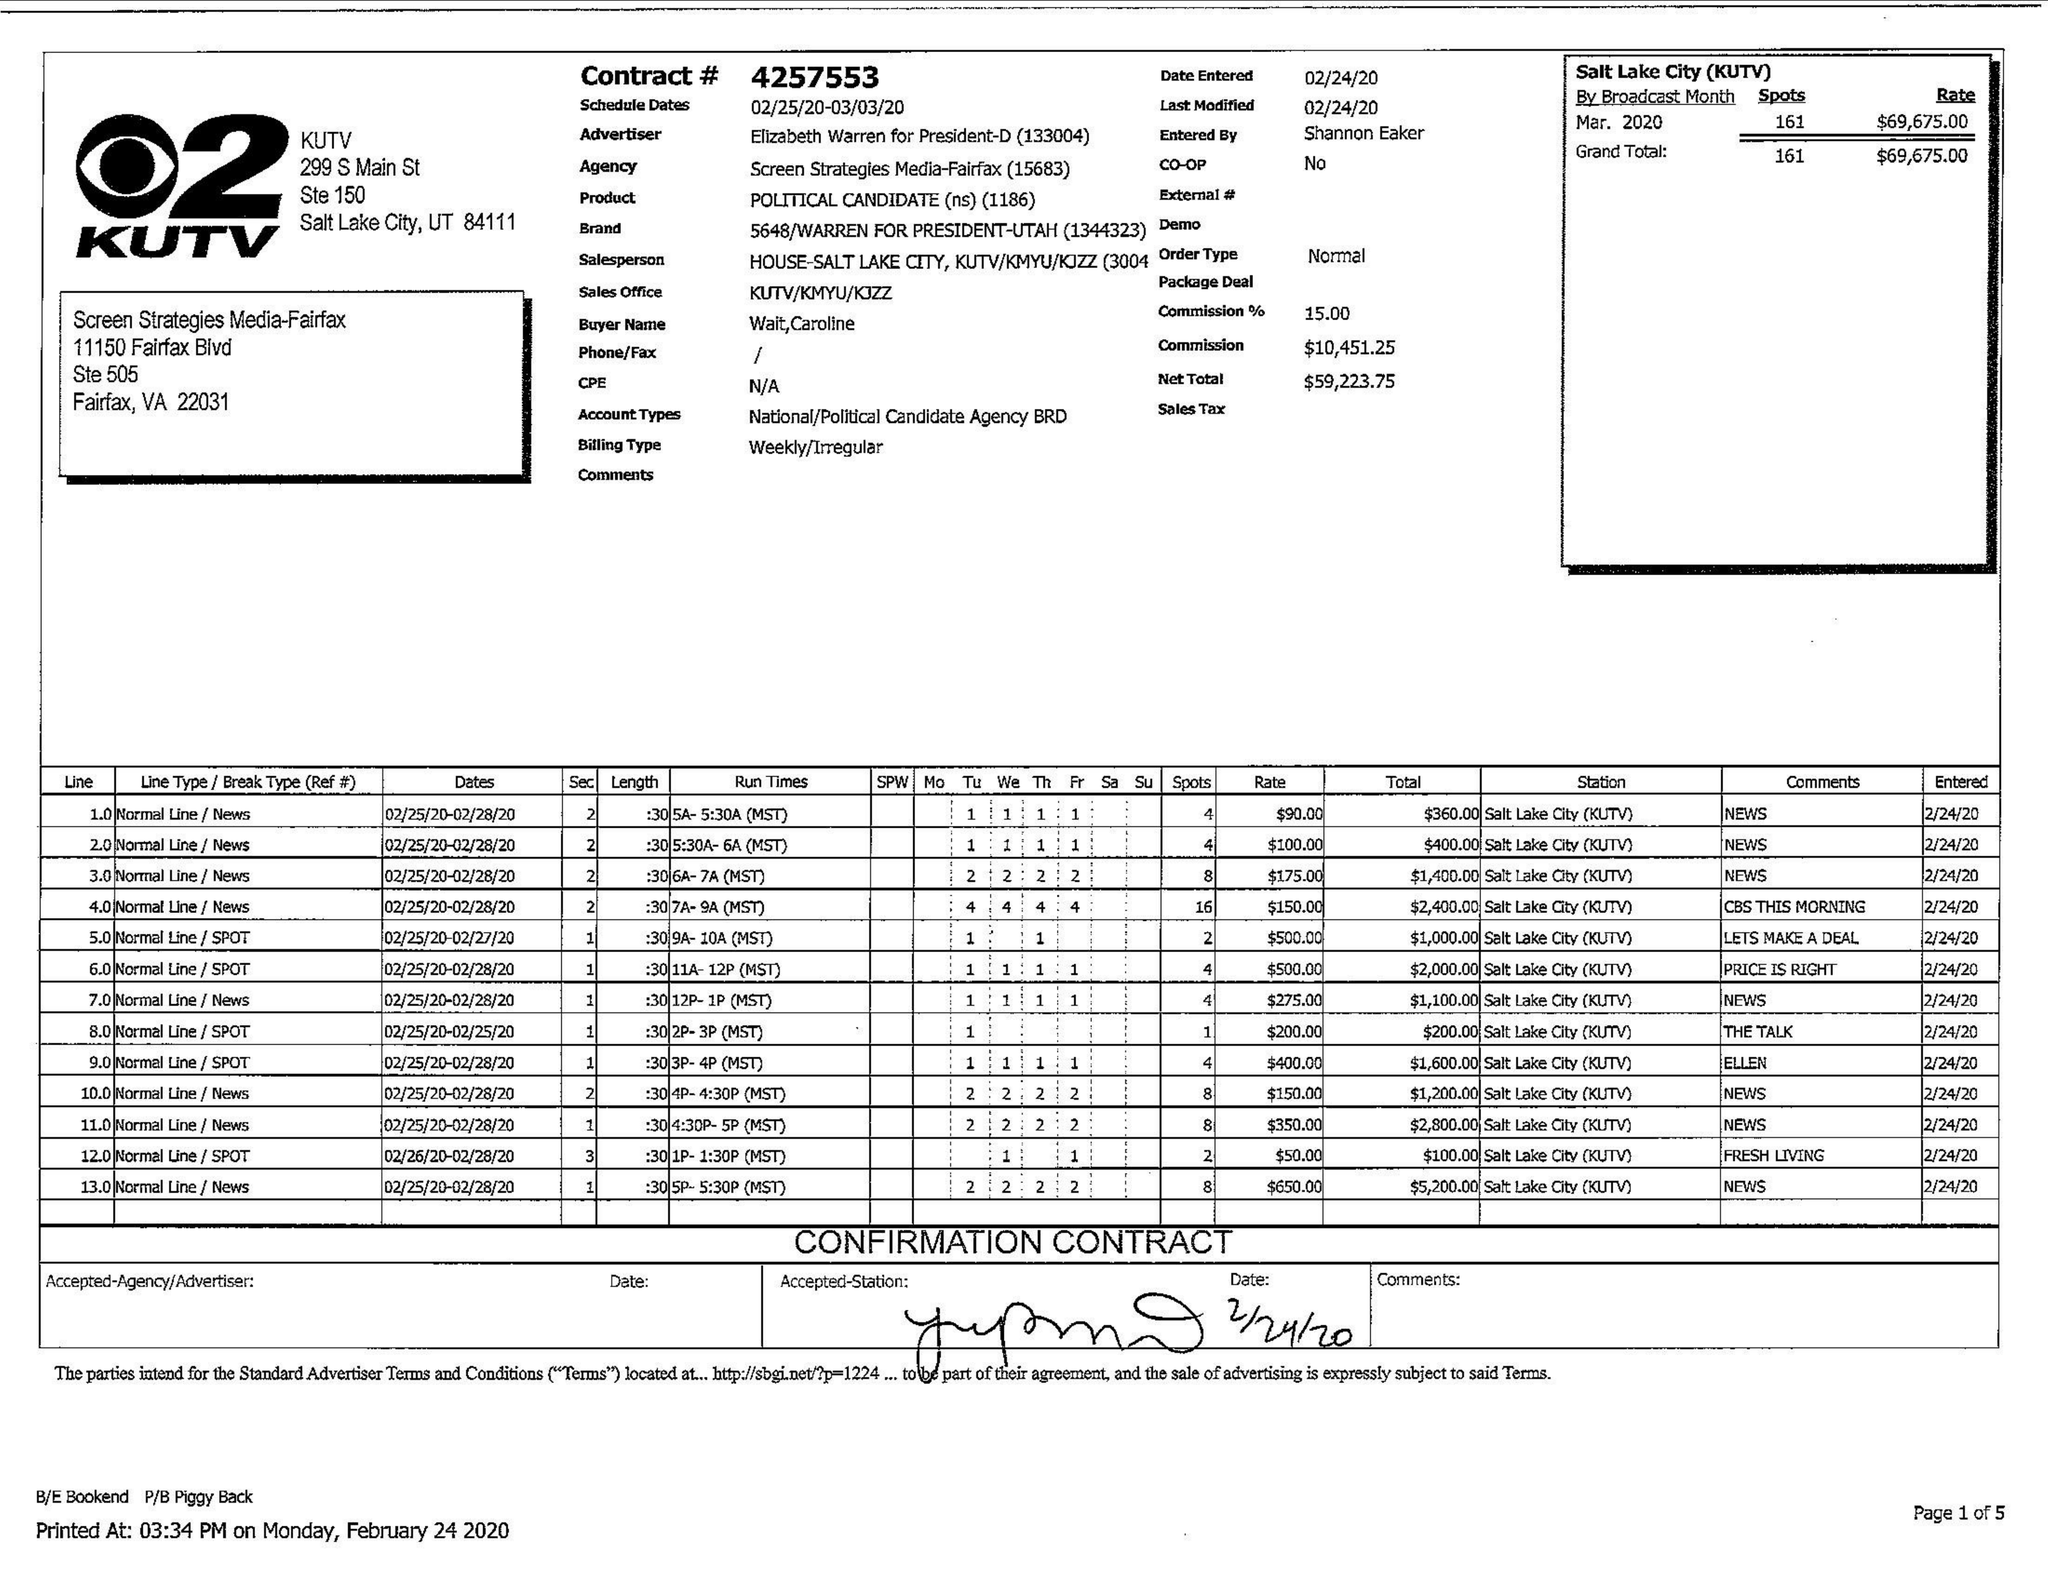What is the value for the gross_amount?
Answer the question using a single word or phrase. 69675.00 